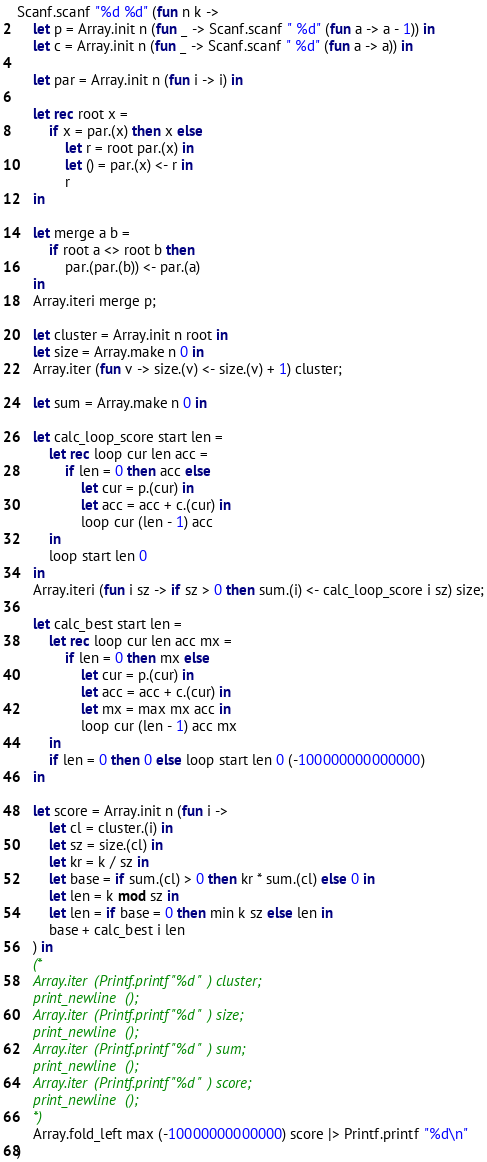Convert code to text. <code><loc_0><loc_0><loc_500><loc_500><_OCaml_>Scanf.scanf "%d %d" (fun n k ->
    let p = Array.init n (fun _ -> Scanf.scanf " %d" (fun a -> a - 1)) in
    let c = Array.init n (fun _ -> Scanf.scanf " %d" (fun a -> a)) in

    let par = Array.init n (fun i -> i) in
    
    let rec root x =
        if x = par.(x) then x else
            let r = root par.(x) in
            let () = par.(x) <- r in
            r
    in

    let merge a b =
        if root a <> root b then
            par.(par.(b)) <- par.(a)
    in
    Array.iteri merge p;

    let cluster = Array.init n root in
    let size = Array.make n 0 in
    Array.iter (fun v -> size.(v) <- size.(v) + 1) cluster;

    let sum = Array.make n 0 in

    let calc_loop_score start len =
        let rec loop cur len acc =
            if len = 0 then acc else
                let cur = p.(cur) in
                let acc = acc + c.(cur) in
                loop cur (len - 1) acc
        in
        loop start len 0
    in
    Array.iteri (fun i sz -> if sz > 0 then sum.(i) <- calc_loop_score i sz) size;

    let calc_best start len =
        let rec loop cur len acc mx =
            if len = 0 then mx else
                let cur = p.(cur) in
                let acc = acc + c.(cur) in
                let mx = max mx acc in
                loop cur (len - 1) acc mx
        in
        if len = 0 then 0 else loop start len 0 (-100000000000000)
    in

    let score = Array.init n (fun i ->
        let cl = cluster.(i) in
        let sz = size.(cl) in
        let kr = k / sz in
        let base = if sum.(cl) > 0 then kr * sum.(cl) else 0 in
        let len = k mod sz in
        let len = if base = 0 then min k sz else len in
        base + calc_best i len
    ) in
    (*
    Array.iter (Printf.printf "%d ") cluster;
    print_newline ();
    Array.iter (Printf.printf "%d ") size;
    print_newline ();
    Array.iter (Printf.printf "%d ") sum;
    print_newline ();
    Array.iter (Printf.printf "%d ") score;
    print_newline ();
    *)
    Array.fold_left max (-10000000000000) score |> Printf.printf "%d\n"
)</code> 